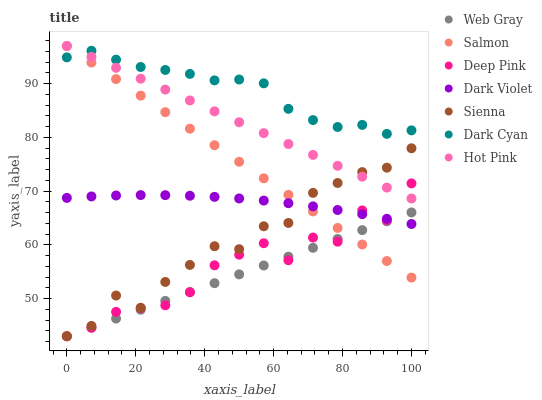Does Web Gray have the minimum area under the curve?
Answer yes or no. Yes. Does Dark Cyan have the maximum area under the curve?
Answer yes or no. Yes. Does Hot Pink have the minimum area under the curve?
Answer yes or no. No. Does Hot Pink have the maximum area under the curve?
Answer yes or no. No. Is Hot Pink the smoothest?
Answer yes or no. Yes. Is Deep Pink the roughest?
Answer yes or no. Yes. Is Salmon the smoothest?
Answer yes or no. No. Is Salmon the roughest?
Answer yes or no. No. Does Web Gray have the lowest value?
Answer yes or no. Yes. Does Hot Pink have the lowest value?
Answer yes or no. No. Does Salmon have the highest value?
Answer yes or no. Yes. Does Dark Violet have the highest value?
Answer yes or no. No. Is Sienna less than Dark Cyan?
Answer yes or no. Yes. Is Dark Cyan greater than Web Gray?
Answer yes or no. Yes. Does Dark Violet intersect Sienna?
Answer yes or no. Yes. Is Dark Violet less than Sienna?
Answer yes or no. No. Is Dark Violet greater than Sienna?
Answer yes or no. No. Does Sienna intersect Dark Cyan?
Answer yes or no. No. 